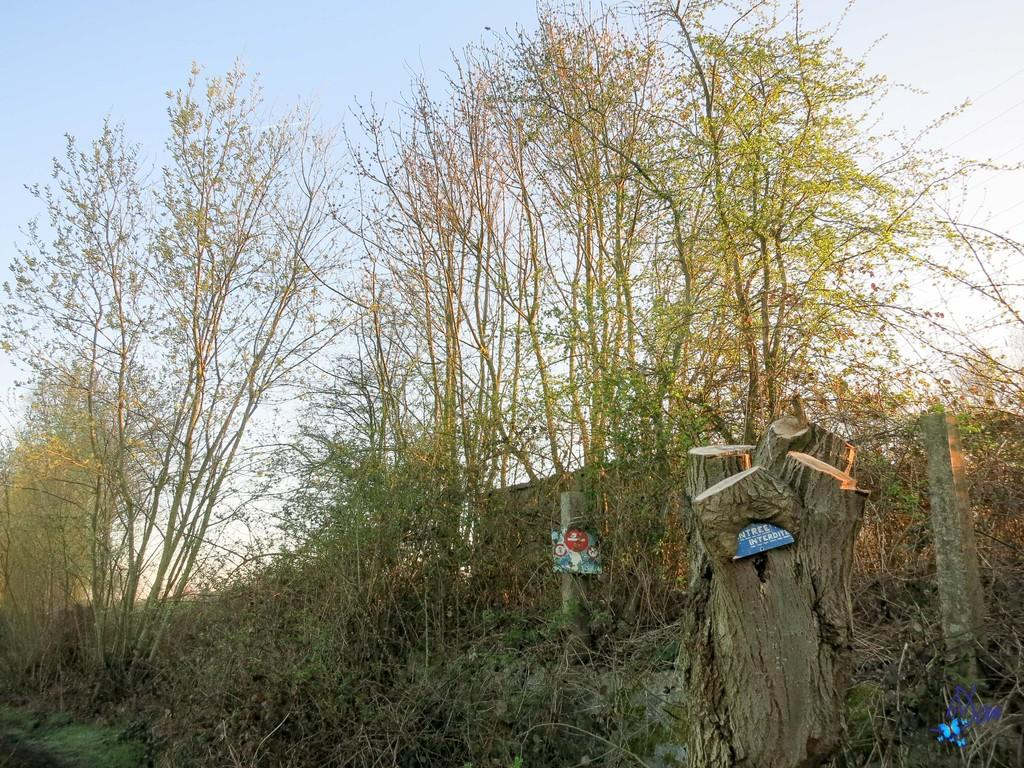What type of vegetation can be seen in the image? There is a group of trees and plants in the image. What man-made objects are present in the image? There is a signboard and poles in the image. Can you describe the texture of the tree bark in the image? The bark of a tree is visible in the image. What is the condition of the sky in the image? The sky is visible in the image, and it looks cloudy. What type of love story is depicted on the prison zipper in the image? There is no love story, prison, or zipper present in the image. 